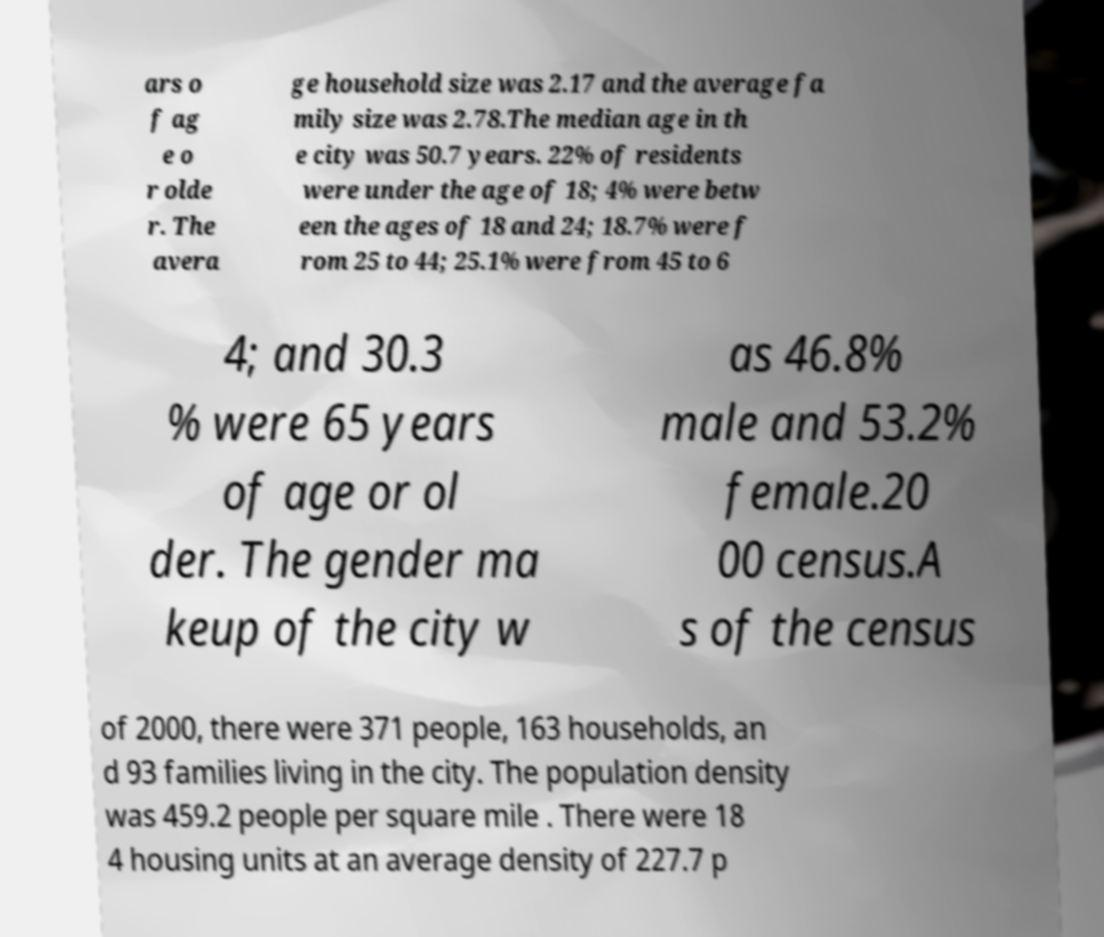Please read and relay the text visible in this image. What does it say? ars o f ag e o r olde r. The avera ge household size was 2.17 and the average fa mily size was 2.78.The median age in th e city was 50.7 years. 22% of residents were under the age of 18; 4% were betw een the ages of 18 and 24; 18.7% were f rom 25 to 44; 25.1% were from 45 to 6 4; and 30.3 % were 65 years of age or ol der. The gender ma keup of the city w as 46.8% male and 53.2% female.20 00 census.A s of the census of 2000, there were 371 people, 163 households, an d 93 families living in the city. The population density was 459.2 people per square mile . There were 18 4 housing units at an average density of 227.7 p 